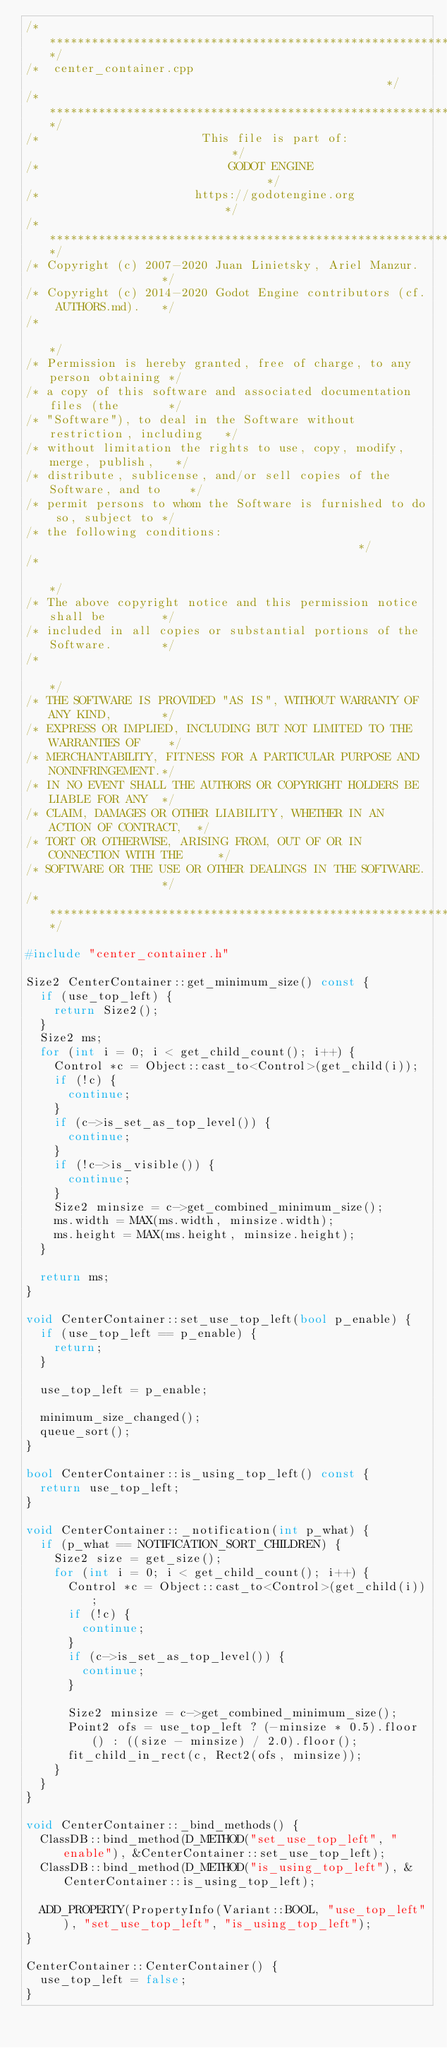<code> <loc_0><loc_0><loc_500><loc_500><_C++_>/*************************************************************************/
/*  center_container.cpp                                                 */
/*************************************************************************/
/*                       This file is part of:                           */
/*                           GODOT ENGINE                                */
/*                      https://godotengine.org                          */
/*************************************************************************/
/* Copyright (c) 2007-2020 Juan Linietsky, Ariel Manzur.                 */
/* Copyright (c) 2014-2020 Godot Engine contributors (cf. AUTHORS.md).   */
/*                                                                       */
/* Permission is hereby granted, free of charge, to any person obtaining */
/* a copy of this software and associated documentation files (the       */
/* "Software"), to deal in the Software without restriction, including   */
/* without limitation the rights to use, copy, modify, merge, publish,   */
/* distribute, sublicense, and/or sell copies of the Software, and to    */
/* permit persons to whom the Software is furnished to do so, subject to */
/* the following conditions:                                             */
/*                                                                       */
/* The above copyright notice and this permission notice shall be        */
/* included in all copies or substantial portions of the Software.       */
/*                                                                       */
/* THE SOFTWARE IS PROVIDED "AS IS", WITHOUT WARRANTY OF ANY KIND,       */
/* EXPRESS OR IMPLIED, INCLUDING BUT NOT LIMITED TO THE WARRANTIES OF    */
/* MERCHANTABILITY, FITNESS FOR A PARTICULAR PURPOSE AND NONINFRINGEMENT.*/
/* IN NO EVENT SHALL THE AUTHORS OR COPYRIGHT HOLDERS BE LIABLE FOR ANY  */
/* CLAIM, DAMAGES OR OTHER LIABILITY, WHETHER IN AN ACTION OF CONTRACT,  */
/* TORT OR OTHERWISE, ARISING FROM, OUT OF OR IN CONNECTION WITH THE     */
/* SOFTWARE OR THE USE OR OTHER DEALINGS IN THE SOFTWARE.                */
/*************************************************************************/

#include "center_container.h"

Size2 CenterContainer::get_minimum_size() const {
	if (use_top_left) {
		return Size2();
	}
	Size2 ms;
	for (int i = 0; i < get_child_count(); i++) {
		Control *c = Object::cast_to<Control>(get_child(i));
		if (!c) {
			continue;
		}
		if (c->is_set_as_top_level()) {
			continue;
		}
		if (!c->is_visible()) {
			continue;
		}
		Size2 minsize = c->get_combined_minimum_size();
		ms.width = MAX(ms.width, minsize.width);
		ms.height = MAX(ms.height, minsize.height);
	}

	return ms;
}

void CenterContainer::set_use_top_left(bool p_enable) {
	if (use_top_left == p_enable) {
		return;
	}

	use_top_left = p_enable;

	minimum_size_changed();
	queue_sort();
}

bool CenterContainer::is_using_top_left() const {
	return use_top_left;
}

void CenterContainer::_notification(int p_what) {
	if (p_what == NOTIFICATION_SORT_CHILDREN) {
		Size2 size = get_size();
		for (int i = 0; i < get_child_count(); i++) {
			Control *c = Object::cast_to<Control>(get_child(i));
			if (!c) {
				continue;
			}
			if (c->is_set_as_top_level()) {
				continue;
			}

			Size2 minsize = c->get_combined_minimum_size();
			Point2 ofs = use_top_left ? (-minsize * 0.5).floor() : ((size - minsize) / 2.0).floor();
			fit_child_in_rect(c, Rect2(ofs, minsize));
		}
	}
}

void CenterContainer::_bind_methods() {
	ClassDB::bind_method(D_METHOD("set_use_top_left", "enable"), &CenterContainer::set_use_top_left);
	ClassDB::bind_method(D_METHOD("is_using_top_left"), &CenterContainer::is_using_top_left);

	ADD_PROPERTY(PropertyInfo(Variant::BOOL, "use_top_left"), "set_use_top_left", "is_using_top_left");
}

CenterContainer::CenterContainer() {
	use_top_left = false;
}
</code> 